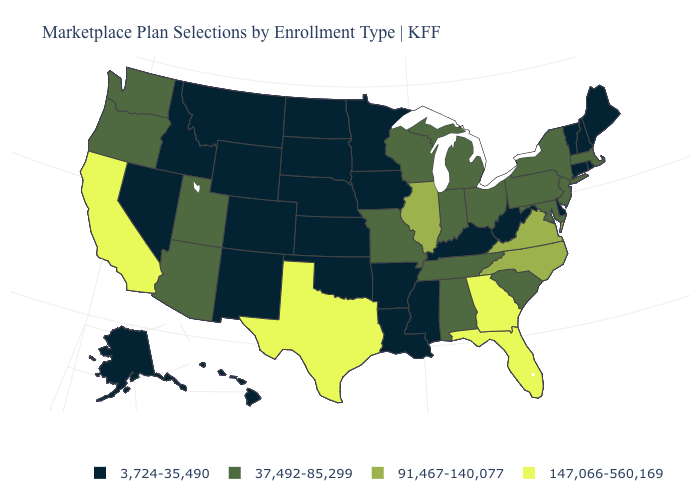What is the value of Delaware?
Give a very brief answer. 3,724-35,490. Name the states that have a value in the range 37,492-85,299?
Answer briefly. Alabama, Arizona, Indiana, Maryland, Massachusetts, Michigan, Missouri, New Jersey, New York, Ohio, Oregon, Pennsylvania, South Carolina, Tennessee, Utah, Washington, Wisconsin. What is the highest value in states that border New Hampshire?
Concise answer only. 37,492-85,299. What is the lowest value in the USA?
Answer briefly. 3,724-35,490. Is the legend a continuous bar?
Answer briefly. No. What is the highest value in the Northeast ?
Answer briefly. 37,492-85,299. Which states have the lowest value in the USA?
Write a very short answer. Alaska, Arkansas, Colorado, Connecticut, Delaware, Hawaii, Idaho, Iowa, Kansas, Kentucky, Louisiana, Maine, Minnesota, Mississippi, Montana, Nebraska, Nevada, New Hampshire, New Mexico, North Dakota, Oklahoma, Rhode Island, South Dakota, Vermont, West Virginia, Wyoming. Among the states that border Pennsylvania , which have the highest value?
Concise answer only. Maryland, New Jersey, New York, Ohio. Name the states that have a value in the range 3,724-35,490?
Be succinct. Alaska, Arkansas, Colorado, Connecticut, Delaware, Hawaii, Idaho, Iowa, Kansas, Kentucky, Louisiana, Maine, Minnesota, Mississippi, Montana, Nebraska, Nevada, New Hampshire, New Mexico, North Dakota, Oklahoma, Rhode Island, South Dakota, Vermont, West Virginia, Wyoming. Name the states that have a value in the range 37,492-85,299?
Quick response, please. Alabama, Arizona, Indiana, Maryland, Massachusetts, Michigan, Missouri, New Jersey, New York, Ohio, Oregon, Pennsylvania, South Carolina, Tennessee, Utah, Washington, Wisconsin. Name the states that have a value in the range 37,492-85,299?
Give a very brief answer. Alabama, Arizona, Indiana, Maryland, Massachusetts, Michigan, Missouri, New Jersey, New York, Ohio, Oregon, Pennsylvania, South Carolina, Tennessee, Utah, Washington, Wisconsin. Name the states that have a value in the range 3,724-35,490?
Be succinct. Alaska, Arkansas, Colorado, Connecticut, Delaware, Hawaii, Idaho, Iowa, Kansas, Kentucky, Louisiana, Maine, Minnesota, Mississippi, Montana, Nebraska, Nevada, New Hampshire, New Mexico, North Dakota, Oklahoma, Rhode Island, South Dakota, Vermont, West Virginia, Wyoming. What is the highest value in states that border Oregon?
Concise answer only. 147,066-560,169. Does the map have missing data?
Give a very brief answer. No. Name the states that have a value in the range 91,467-140,077?
Write a very short answer. Illinois, North Carolina, Virginia. 